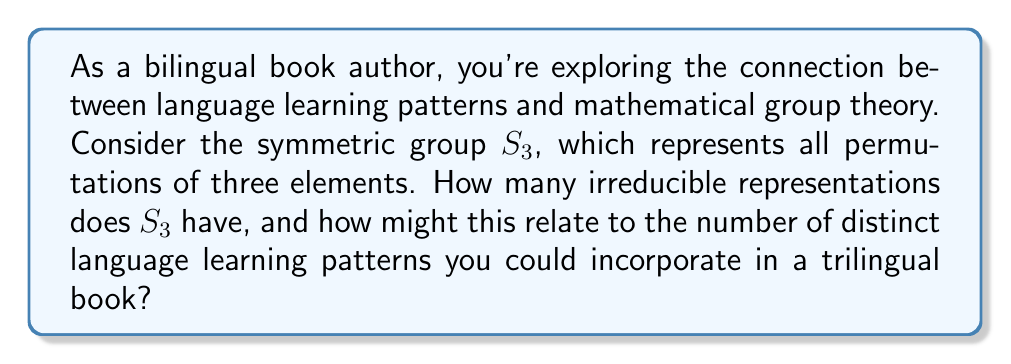Teach me how to tackle this problem. 1) First, let's analyze the structure of $S_3$:
   $S_3$ has 6 elements: $\{e, (12), (13), (23), (123), (132)\}$

2) To find the number of irreducible representations, we use the formula:
   Number of irreducible representations = Number of conjugacy classes

3) Let's identify the conjugacy classes of $S_3$:
   - $\{e\}$: identity
   - $\{(12), (13), (23)\}$: transpositions
   - $\{(123), (132)\}$: 3-cycles

4) There are 3 conjugacy classes, so $S_3$ has 3 irreducible representations.

5) The dimensions of these representations are:
   - 1-dimensional trivial representation
   - 1-dimensional sign representation
   - 2-dimensional standard representation

6) Relating to language learning:
   - The trivial representation could correspond to universal language patterns.
   - The sign representation might represent binary language distinctions (e.g., formal vs. informal).
   - The 2-dimensional representation could represent more complex language interactions.

7) In a trilingual book, these could translate to:
   - Patterns common to all three languages
   - Patterns that distinguish one language from the other two
   - Patterns that show complex interactions between all three languages

Therefore, the structure of $S_3$ suggests at least three distinct types of language learning patterns that could be incorporated into a trilingual book.
Answer: 3 irreducible representations, corresponding to 3 types of language learning patterns 